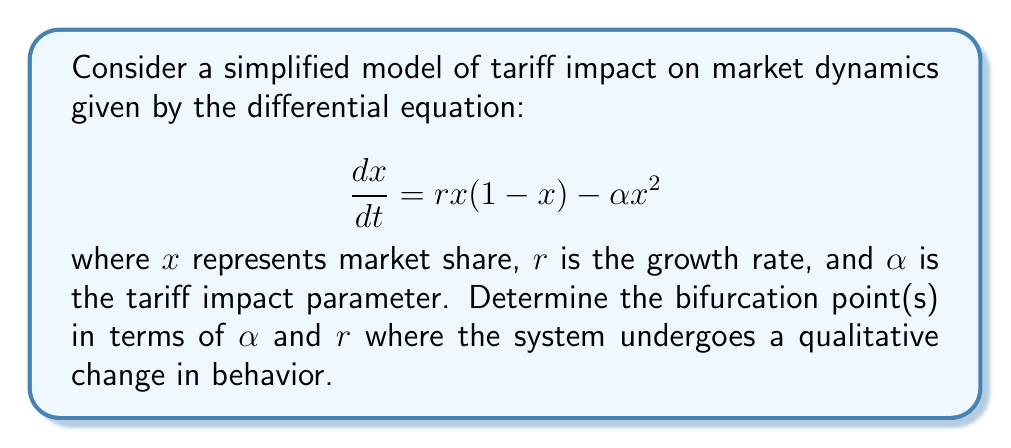Provide a solution to this math problem. To find the bifurcation points, we need to follow these steps:

1) First, find the equilibrium points by setting $\frac{dx}{dt} = 0$:

   $$rx(1-x) - \alpha x^2 = 0$$
   $$x(r-rx-\alpha x) = 0$$

2) Solve for $x$:
   $x = 0$ or $r-rx-\alpha x = 0$
   
   For the second equation: $x(r-\alpha) = r$
   $x = \frac{r}{r-\alpha}$ (when $r \neq \alpha$)

3) The system undergoes a bifurcation when the non-zero equilibrium point coincides with the zero equilibrium point, or when it doesn't exist. This happens when the denominator of $\frac{r}{r-\alpha}$ is zero, i.e., when $r = \alpha$.

4) At this point ($r = \alpha$), the system changes from having two equilibrium points to having only one (at $x = 0$). This is known as a transcritical bifurcation.

5) We can also observe that when $\alpha > r$, the non-zero equilibrium point becomes negative, which is not meaningful in the context of market share. This further confirms that $r = \alpha$ is indeed the bifurcation point.

Therefore, the bifurcation occurs when the tariff impact parameter $\alpha$ equals the growth rate $r$.
Answer: $\alpha = r$ 